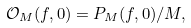<formula> <loc_0><loc_0><loc_500><loc_500>\mathcal { O } _ { M } ( f , 0 ) = P _ { M } ( f , 0 ) / M ,</formula> 